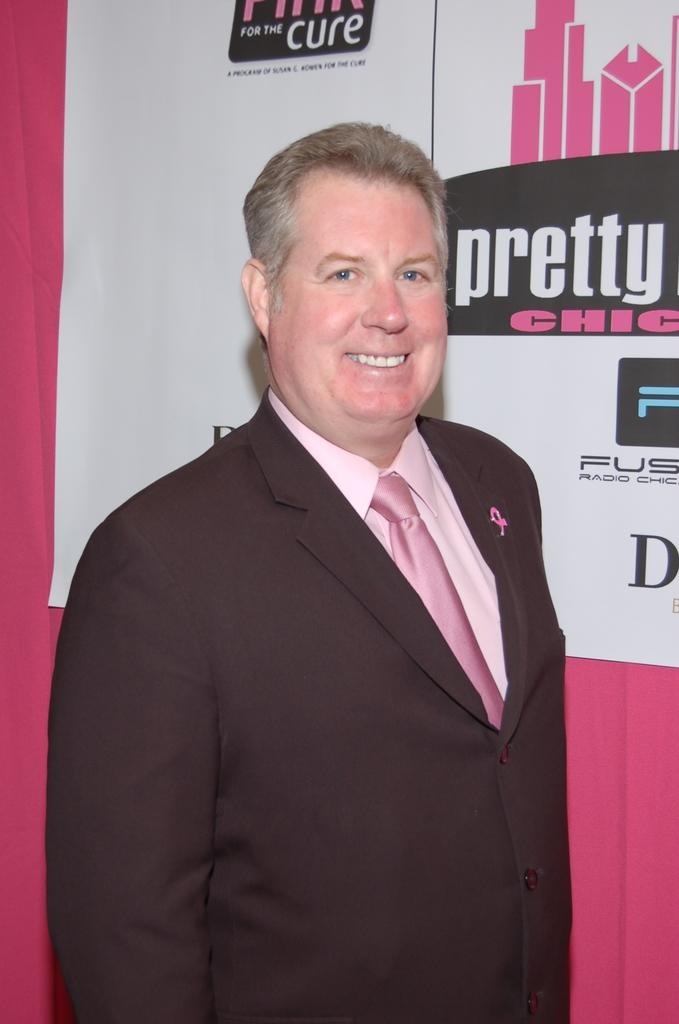<image>
Share a concise interpretation of the image provided. A middle aged man in a suit is posing for a photo as he stands in front of posters that encourage the drive to find a cure for breast cancer. 